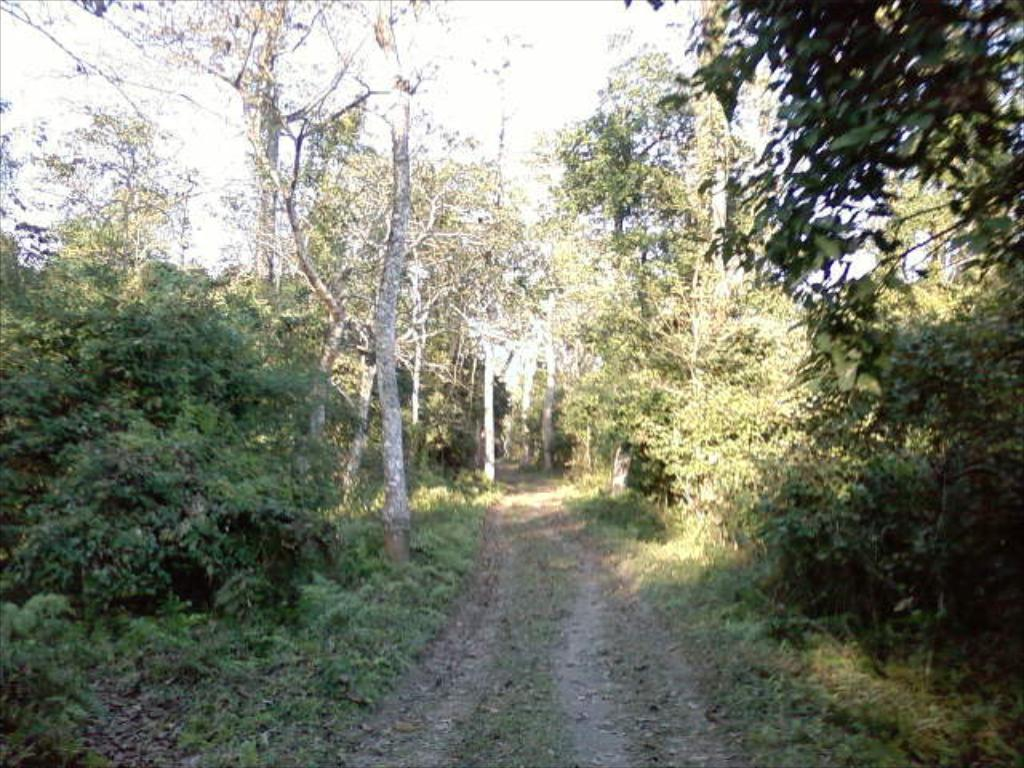What is the main feature in the middle of the image? There is a path in the middle of the image. What can be seen on both sides of the path? There are trees on both sides of the path. What is the condition of the sky in the image? The sky is clear in the image. What type of pancake is being served in harmony with the trees in the image? There is no pancake present in the image, and the concept of harmony with the trees is not applicable to the image. 